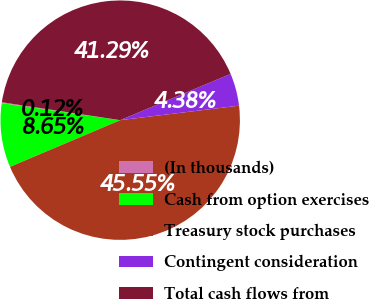Convert chart to OTSL. <chart><loc_0><loc_0><loc_500><loc_500><pie_chart><fcel>(In thousands)<fcel>Cash from option exercises<fcel>Treasury stock purchases<fcel>Contingent consideration<fcel>Total cash flows from<nl><fcel>0.12%<fcel>8.65%<fcel>45.55%<fcel>4.38%<fcel>41.29%<nl></chart> 